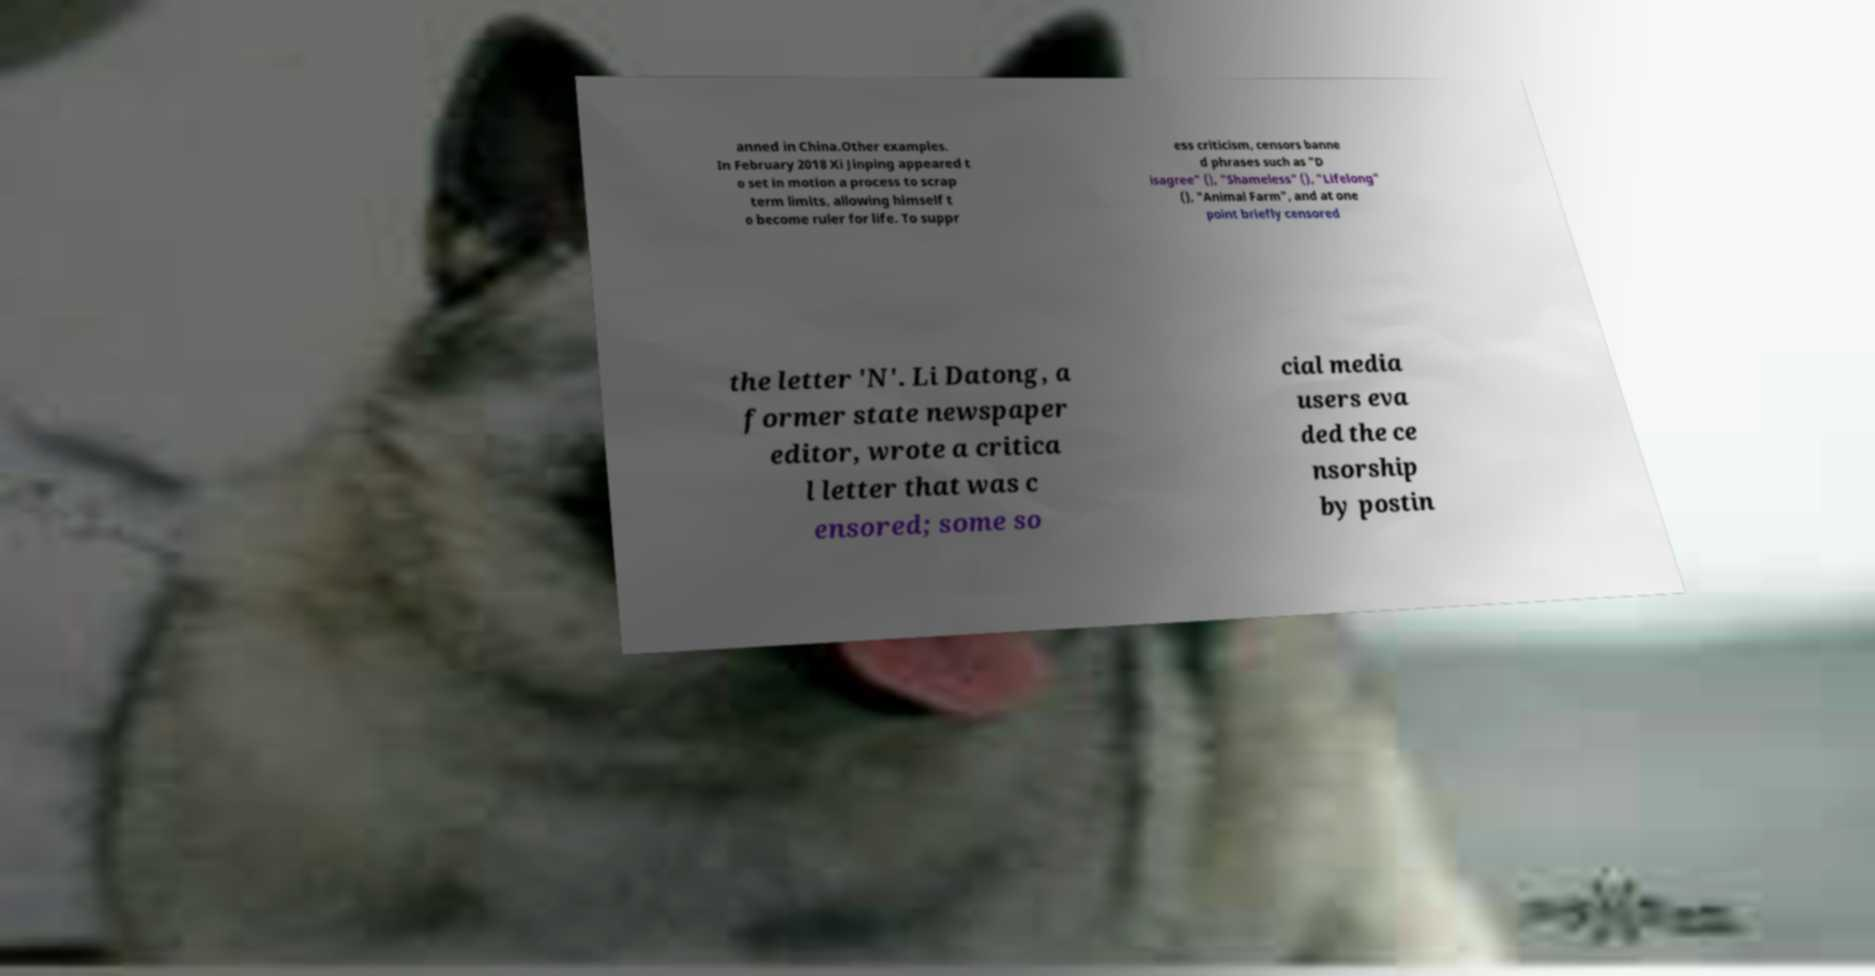I need the written content from this picture converted into text. Can you do that? anned in China.Other examples. In February 2018 Xi Jinping appeared t o set in motion a process to scrap term limits, allowing himself t o become ruler for life. To suppr ess criticism, censors banne d phrases such as "D isagree" (), "Shameless" (), "Lifelong" (), "Animal Farm", and at one point briefly censored the letter 'N'. Li Datong, a former state newspaper editor, wrote a critica l letter that was c ensored; some so cial media users eva ded the ce nsorship by postin 